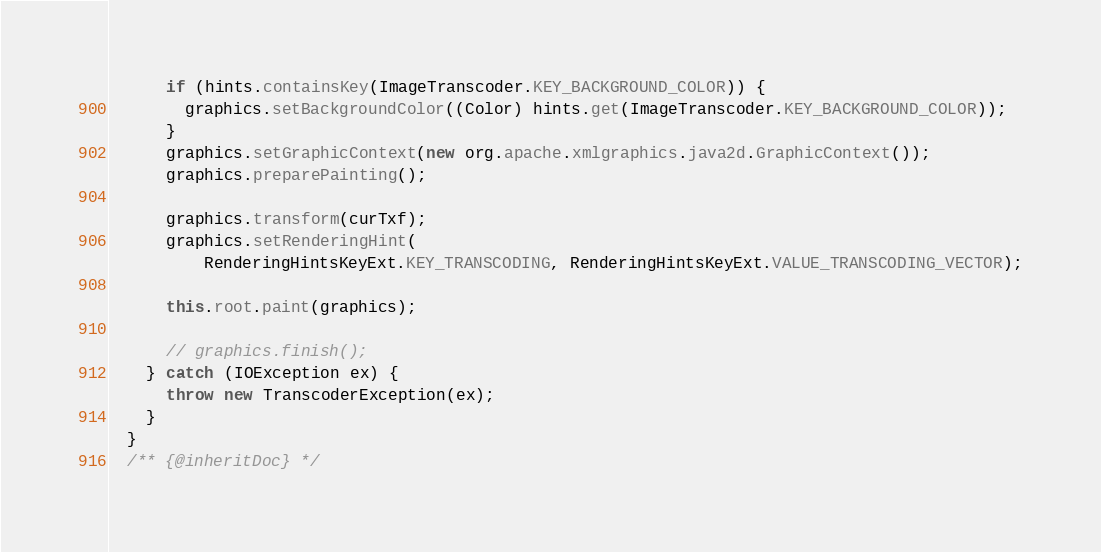<code> <loc_0><loc_0><loc_500><loc_500><_Java_>      if (hints.containsKey(ImageTranscoder.KEY_BACKGROUND_COLOR)) {
        graphics.setBackgroundColor((Color) hints.get(ImageTranscoder.KEY_BACKGROUND_COLOR));
      }
      graphics.setGraphicContext(new org.apache.xmlgraphics.java2d.GraphicContext());
      graphics.preparePainting();

      graphics.transform(curTxf);
      graphics.setRenderingHint(
          RenderingHintsKeyExt.KEY_TRANSCODING, RenderingHintsKeyExt.VALUE_TRANSCODING_VECTOR);

      this.root.paint(graphics);

      // graphics.finish();
    } catch (IOException ex) {
      throw new TranscoderException(ex);
    }
  }
  /** {@inheritDoc} */</code> 